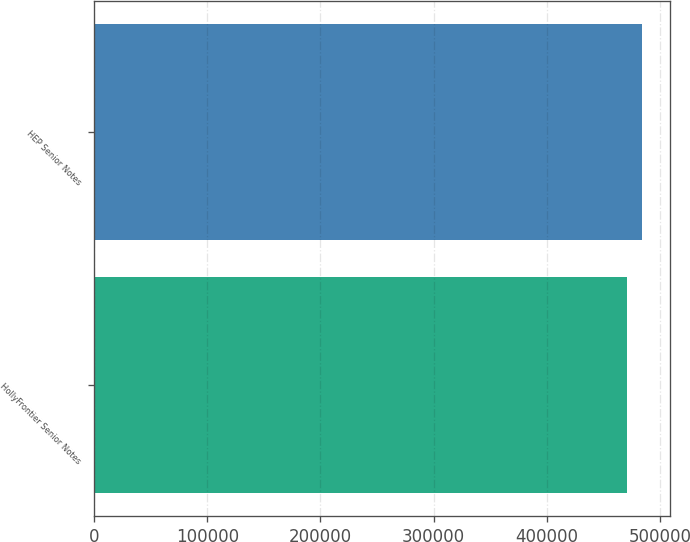<chart> <loc_0><loc_0><loc_500><loc_500><bar_chart><fcel>HollyFrontier Senior Notes<fcel>HEP Senior Notes<nl><fcel>470990<fcel>484125<nl></chart> 